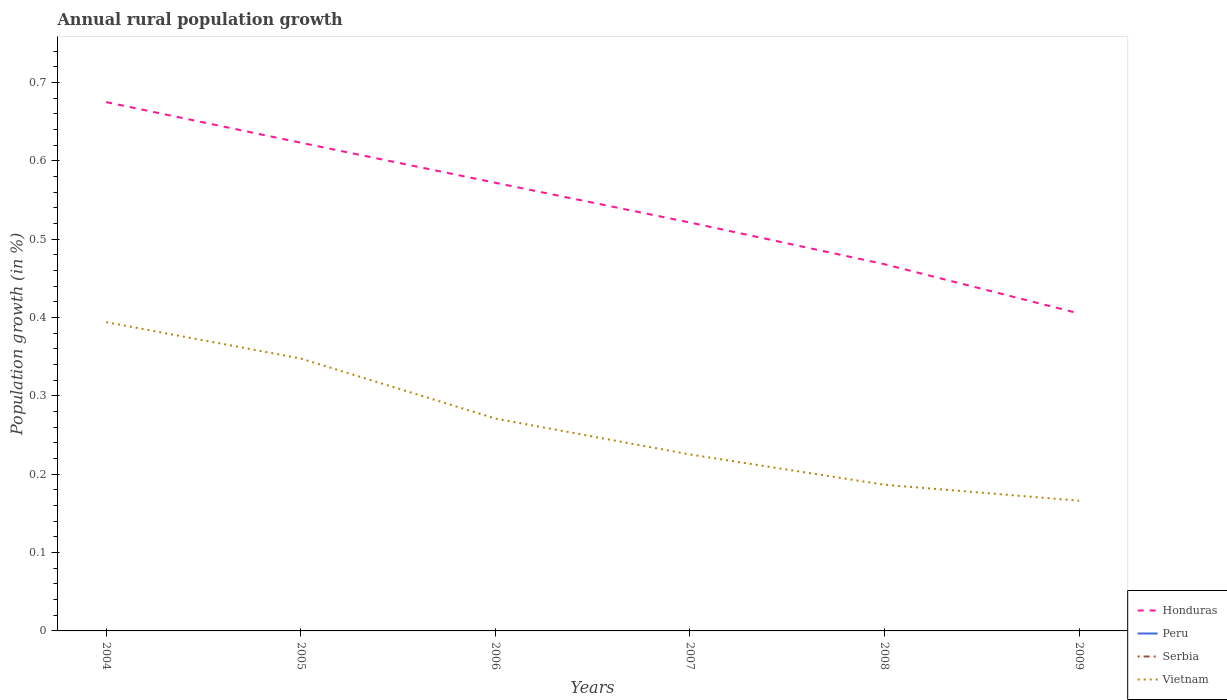Does the line corresponding to Peru intersect with the line corresponding to Serbia?
Your response must be concise. No. Across all years, what is the maximum percentage of rural population growth in Serbia?
Your answer should be compact. 0. What is the total percentage of rural population growth in Honduras in the graph?
Ensure brevity in your answer.  0.1. What is the difference between the highest and the second highest percentage of rural population growth in Honduras?
Provide a succinct answer. 0.27. What is the difference between the highest and the lowest percentage of rural population growth in Honduras?
Keep it short and to the point. 3. Are the values on the major ticks of Y-axis written in scientific E-notation?
Offer a terse response. No. Does the graph contain grids?
Provide a succinct answer. No. How many legend labels are there?
Keep it short and to the point. 4. What is the title of the graph?
Offer a terse response. Annual rural population growth. Does "Antigua and Barbuda" appear as one of the legend labels in the graph?
Your response must be concise. No. What is the label or title of the Y-axis?
Ensure brevity in your answer.  Population growth (in %). What is the Population growth (in %) in Honduras in 2004?
Offer a very short reply. 0.68. What is the Population growth (in %) of Peru in 2004?
Provide a succinct answer. 0. What is the Population growth (in %) of Vietnam in 2004?
Offer a terse response. 0.39. What is the Population growth (in %) in Honduras in 2005?
Your response must be concise. 0.62. What is the Population growth (in %) of Peru in 2005?
Give a very brief answer. 0. What is the Population growth (in %) of Vietnam in 2005?
Give a very brief answer. 0.35. What is the Population growth (in %) of Honduras in 2006?
Your answer should be compact. 0.57. What is the Population growth (in %) in Vietnam in 2006?
Your answer should be compact. 0.27. What is the Population growth (in %) of Honduras in 2007?
Ensure brevity in your answer.  0.52. What is the Population growth (in %) in Vietnam in 2007?
Offer a very short reply. 0.23. What is the Population growth (in %) of Honduras in 2008?
Provide a succinct answer. 0.47. What is the Population growth (in %) in Serbia in 2008?
Your answer should be compact. 0. What is the Population growth (in %) of Vietnam in 2008?
Offer a terse response. 0.19. What is the Population growth (in %) in Honduras in 2009?
Keep it short and to the point. 0.41. What is the Population growth (in %) of Serbia in 2009?
Your answer should be compact. 0. What is the Population growth (in %) in Vietnam in 2009?
Your answer should be compact. 0.17. Across all years, what is the maximum Population growth (in %) of Honduras?
Provide a short and direct response. 0.68. Across all years, what is the maximum Population growth (in %) in Vietnam?
Provide a succinct answer. 0.39. Across all years, what is the minimum Population growth (in %) of Honduras?
Give a very brief answer. 0.41. Across all years, what is the minimum Population growth (in %) in Vietnam?
Keep it short and to the point. 0.17. What is the total Population growth (in %) of Honduras in the graph?
Ensure brevity in your answer.  3.27. What is the total Population growth (in %) in Peru in the graph?
Offer a very short reply. 0. What is the total Population growth (in %) of Serbia in the graph?
Your answer should be compact. 0. What is the total Population growth (in %) of Vietnam in the graph?
Ensure brevity in your answer.  1.59. What is the difference between the Population growth (in %) of Honduras in 2004 and that in 2005?
Give a very brief answer. 0.05. What is the difference between the Population growth (in %) of Vietnam in 2004 and that in 2005?
Ensure brevity in your answer.  0.05. What is the difference between the Population growth (in %) in Honduras in 2004 and that in 2006?
Your answer should be compact. 0.1. What is the difference between the Population growth (in %) in Vietnam in 2004 and that in 2006?
Make the answer very short. 0.12. What is the difference between the Population growth (in %) in Honduras in 2004 and that in 2007?
Offer a very short reply. 0.15. What is the difference between the Population growth (in %) of Vietnam in 2004 and that in 2007?
Your response must be concise. 0.17. What is the difference between the Population growth (in %) of Honduras in 2004 and that in 2008?
Keep it short and to the point. 0.21. What is the difference between the Population growth (in %) of Vietnam in 2004 and that in 2008?
Provide a succinct answer. 0.21. What is the difference between the Population growth (in %) in Honduras in 2004 and that in 2009?
Provide a succinct answer. 0.27. What is the difference between the Population growth (in %) in Vietnam in 2004 and that in 2009?
Provide a short and direct response. 0.23. What is the difference between the Population growth (in %) of Honduras in 2005 and that in 2006?
Offer a terse response. 0.05. What is the difference between the Population growth (in %) of Vietnam in 2005 and that in 2006?
Provide a succinct answer. 0.08. What is the difference between the Population growth (in %) in Honduras in 2005 and that in 2007?
Your answer should be very brief. 0.1. What is the difference between the Population growth (in %) of Vietnam in 2005 and that in 2007?
Make the answer very short. 0.12. What is the difference between the Population growth (in %) in Honduras in 2005 and that in 2008?
Ensure brevity in your answer.  0.16. What is the difference between the Population growth (in %) in Vietnam in 2005 and that in 2008?
Your answer should be very brief. 0.16. What is the difference between the Population growth (in %) of Honduras in 2005 and that in 2009?
Give a very brief answer. 0.22. What is the difference between the Population growth (in %) in Vietnam in 2005 and that in 2009?
Give a very brief answer. 0.18. What is the difference between the Population growth (in %) in Honduras in 2006 and that in 2007?
Keep it short and to the point. 0.05. What is the difference between the Population growth (in %) of Vietnam in 2006 and that in 2007?
Provide a succinct answer. 0.05. What is the difference between the Population growth (in %) of Honduras in 2006 and that in 2008?
Your answer should be very brief. 0.1. What is the difference between the Population growth (in %) in Vietnam in 2006 and that in 2008?
Offer a terse response. 0.08. What is the difference between the Population growth (in %) of Honduras in 2006 and that in 2009?
Offer a terse response. 0.17. What is the difference between the Population growth (in %) in Vietnam in 2006 and that in 2009?
Offer a terse response. 0.1. What is the difference between the Population growth (in %) of Honduras in 2007 and that in 2008?
Ensure brevity in your answer.  0.05. What is the difference between the Population growth (in %) of Vietnam in 2007 and that in 2008?
Your answer should be very brief. 0.04. What is the difference between the Population growth (in %) in Honduras in 2007 and that in 2009?
Your answer should be very brief. 0.12. What is the difference between the Population growth (in %) in Vietnam in 2007 and that in 2009?
Your answer should be compact. 0.06. What is the difference between the Population growth (in %) of Honduras in 2008 and that in 2009?
Keep it short and to the point. 0.06. What is the difference between the Population growth (in %) of Vietnam in 2008 and that in 2009?
Offer a very short reply. 0.02. What is the difference between the Population growth (in %) of Honduras in 2004 and the Population growth (in %) of Vietnam in 2005?
Keep it short and to the point. 0.33. What is the difference between the Population growth (in %) in Honduras in 2004 and the Population growth (in %) in Vietnam in 2006?
Offer a terse response. 0.4. What is the difference between the Population growth (in %) of Honduras in 2004 and the Population growth (in %) of Vietnam in 2007?
Ensure brevity in your answer.  0.45. What is the difference between the Population growth (in %) in Honduras in 2004 and the Population growth (in %) in Vietnam in 2008?
Offer a very short reply. 0.49. What is the difference between the Population growth (in %) of Honduras in 2004 and the Population growth (in %) of Vietnam in 2009?
Your answer should be compact. 0.51. What is the difference between the Population growth (in %) in Honduras in 2005 and the Population growth (in %) in Vietnam in 2006?
Provide a succinct answer. 0.35. What is the difference between the Population growth (in %) in Honduras in 2005 and the Population growth (in %) in Vietnam in 2007?
Make the answer very short. 0.4. What is the difference between the Population growth (in %) of Honduras in 2005 and the Population growth (in %) of Vietnam in 2008?
Ensure brevity in your answer.  0.44. What is the difference between the Population growth (in %) of Honduras in 2005 and the Population growth (in %) of Vietnam in 2009?
Ensure brevity in your answer.  0.46. What is the difference between the Population growth (in %) in Honduras in 2006 and the Population growth (in %) in Vietnam in 2007?
Keep it short and to the point. 0.35. What is the difference between the Population growth (in %) of Honduras in 2006 and the Population growth (in %) of Vietnam in 2008?
Provide a short and direct response. 0.39. What is the difference between the Population growth (in %) of Honduras in 2006 and the Population growth (in %) of Vietnam in 2009?
Give a very brief answer. 0.41. What is the difference between the Population growth (in %) in Honduras in 2007 and the Population growth (in %) in Vietnam in 2008?
Keep it short and to the point. 0.33. What is the difference between the Population growth (in %) in Honduras in 2007 and the Population growth (in %) in Vietnam in 2009?
Your answer should be compact. 0.36. What is the difference between the Population growth (in %) of Honduras in 2008 and the Population growth (in %) of Vietnam in 2009?
Provide a short and direct response. 0.3. What is the average Population growth (in %) in Honduras per year?
Make the answer very short. 0.54. What is the average Population growth (in %) in Vietnam per year?
Your response must be concise. 0.27. In the year 2004, what is the difference between the Population growth (in %) of Honduras and Population growth (in %) of Vietnam?
Offer a very short reply. 0.28. In the year 2005, what is the difference between the Population growth (in %) in Honduras and Population growth (in %) in Vietnam?
Your answer should be very brief. 0.28. In the year 2006, what is the difference between the Population growth (in %) of Honduras and Population growth (in %) of Vietnam?
Ensure brevity in your answer.  0.3. In the year 2007, what is the difference between the Population growth (in %) of Honduras and Population growth (in %) of Vietnam?
Offer a terse response. 0.3. In the year 2008, what is the difference between the Population growth (in %) of Honduras and Population growth (in %) of Vietnam?
Make the answer very short. 0.28. In the year 2009, what is the difference between the Population growth (in %) in Honduras and Population growth (in %) in Vietnam?
Offer a very short reply. 0.24. What is the ratio of the Population growth (in %) of Honduras in 2004 to that in 2005?
Ensure brevity in your answer.  1.08. What is the ratio of the Population growth (in %) of Vietnam in 2004 to that in 2005?
Your answer should be very brief. 1.13. What is the ratio of the Population growth (in %) of Honduras in 2004 to that in 2006?
Provide a succinct answer. 1.18. What is the ratio of the Population growth (in %) of Vietnam in 2004 to that in 2006?
Provide a short and direct response. 1.45. What is the ratio of the Population growth (in %) of Honduras in 2004 to that in 2007?
Your answer should be compact. 1.29. What is the ratio of the Population growth (in %) of Vietnam in 2004 to that in 2007?
Give a very brief answer. 1.75. What is the ratio of the Population growth (in %) of Honduras in 2004 to that in 2008?
Keep it short and to the point. 1.44. What is the ratio of the Population growth (in %) in Vietnam in 2004 to that in 2008?
Offer a very short reply. 2.11. What is the ratio of the Population growth (in %) of Honduras in 2004 to that in 2009?
Give a very brief answer. 1.67. What is the ratio of the Population growth (in %) in Vietnam in 2004 to that in 2009?
Ensure brevity in your answer.  2.37. What is the ratio of the Population growth (in %) of Honduras in 2005 to that in 2006?
Your response must be concise. 1.09. What is the ratio of the Population growth (in %) of Vietnam in 2005 to that in 2006?
Your answer should be compact. 1.28. What is the ratio of the Population growth (in %) in Honduras in 2005 to that in 2007?
Keep it short and to the point. 1.2. What is the ratio of the Population growth (in %) of Vietnam in 2005 to that in 2007?
Make the answer very short. 1.54. What is the ratio of the Population growth (in %) of Honduras in 2005 to that in 2008?
Make the answer very short. 1.33. What is the ratio of the Population growth (in %) of Vietnam in 2005 to that in 2008?
Your answer should be very brief. 1.86. What is the ratio of the Population growth (in %) of Honduras in 2005 to that in 2009?
Provide a short and direct response. 1.54. What is the ratio of the Population growth (in %) of Vietnam in 2005 to that in 2009?
Provide a short and direct response. 2.09. What is the ratio of the Population growth (in %) of Honduras in 2006 to that in 2007?
Give a very brief answer. 1.1. What is the ratio of the Population growth (in %) in Vietnam in 2006 to that in 2007?
Your answer should be compact. 1.2. What is the ratio of the Population growth (in %) of Honduras in 2006 to that in 2008?
Your answer should be very brief. 1.22. What is the ratio of the Population growth (in %) of Vietnam in 2006 to that in 2008?
Keep it short and to the point. 1.45. What is the ratio of the Population growth (in %) in Honduras in 2006 to that in 2009?
Ensure brevity in your answer.  1.41. What is the ratio of the Population growth (in %) in Vietnam in 2006 to that in 2009?
Ensure brevity in your answer.  1.63. What is the ratio of the Population growth (in %) of Honduras in 2007 to that in 2008?
Keep it short and to the point. 1.11. What is the ratio of the Population growth (in %) in Vietnam in 2007 to that in 2008?
Your answer should be compact. 1.21. What is the ratio of the Population growth (in %) of Honduras in 2007 to that in 2009?
Ensure brevity in your answer.  1.29. What is the ratio of the Population growth (in %) in Vietnam in 2007 to that in 2009?
Ensure brevity in your answer.  1.36. What is the ratio of the Population growth (in %) of Honduras in 2008 to that in 2009?
Your answer should be very brief. 1.16. What is the ratio of the Population growth (in %) of Vietnam in 2008 to that in 2009?
Offer a terse response. 1.12. What is the difference between the highest and the second highest Population growth (in %) in Honduras?
Provide a succinct answer. 0.05. What is the difference between the highest and the second highest Population growth (in %) in Vietnam?
Your response must be concise. 0.05. What is the difference between the highest and the lowest Population growth (in %) in Honduras?
Provide a short and direct response. 0.27. What is the difference between the highest and the lowest Population growth (in %) in Vietnam?
Offer a very short reply. 0.23. 